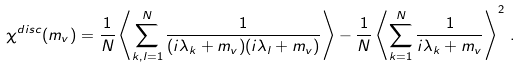Convert formula to latex. <formula><loc_0><loc_0><loc_500><loc_500>\chi ^ { d i s c } ( m _ { v } ) = \frac { 1 } { N } \left \langle \sum _ { k , l = 1 } ^ { N } \frac { 1 } { ( i \lambda _ { k } + m _ { v } ) ( i \lambda _ { l } + m _ { v } ) } \right \rangle - \frac { 1 } { N } \left \langle \sum _ { k = 1 } ^ { N } \frac { 1 } { i \lambda _ { k } + m _ { v } } \right \rangle ^ { 2 } \, .</formula> 